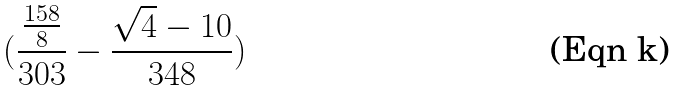<formula> <loc_0><loc_0><loc_500><loc_500>( \frac { \frac { 1 5 8 } { 8 } } { 3 0 3 } - \frac { \sqrt { 4 } - 1 0 } { 3 4 8 } )</formula> 